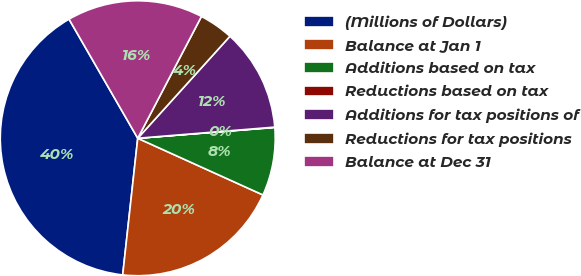Convert chart. <chart><loc_0><loc_0><loc_500><loc_500><pie_chart><fcel>(Millions of Dollars)<fcel>Balance at Jan 1<fcel>Additions based on tax<fcel>Reductions based on tax<fcel>Additions for tax positions of<fcel>Reductions for tax positions<fcel>Balance at Dec 31<nl><fcel>39.93%<fcel>19.98%<fcel>8.02%<fcel>0.04%<fcel>12.01%<fcel>4.03%<fcel>16.0%<nl></chart> 